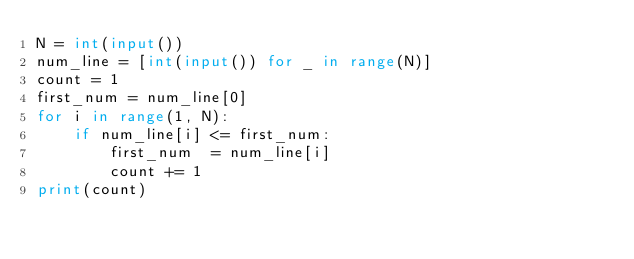<code> <loc_0><loc_0><loc_500><loc_500><_Python_>N = int(input())
num_line = [int(input()) for _ in range(N)]
count = 1
first_num = num_line[0]
for i in range(1, N):
    if num_line[i] <= first_num:
        first_num  = num_line[i]
        count += 1
print(count)</code> 